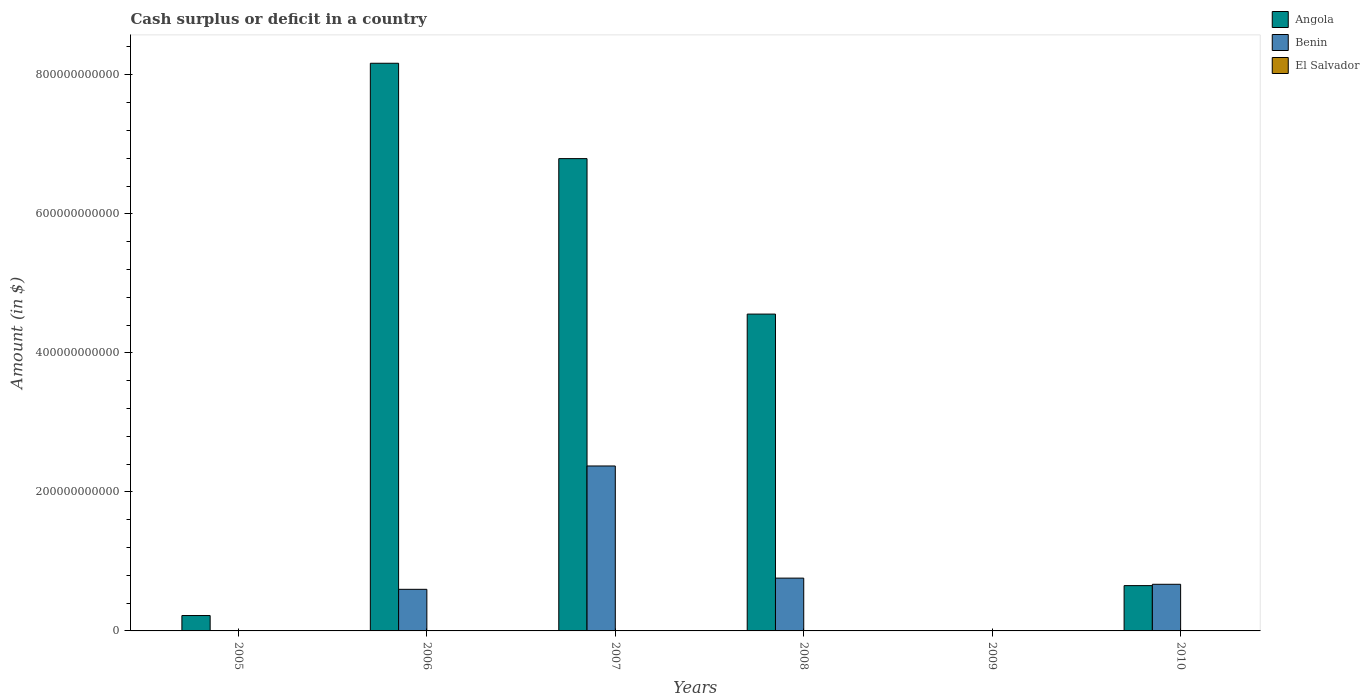How many bars are there on the 3rd tick from the left?
Your answer should be compact. 3. What is the label of the 4th group of bars from the left?
Provide a succinct answer. 2008. In how many cases, is the number of bars for a given year not equal to the number of legend labels?
Make the answer very short. 4. Across all years, what is the maximum amount of cash surplus or deficit in El Salvador?
Ensure brevity in your answer.  1.68e+08. What is the total amount of cash surplus or deficit in El Salvador in the graph?
Your answer should be compact. 2.39e+08. What is the difference between the amount of cash surplus or deficit in Benin in 2006 and that in 2010?
Give a very brief answer. -7.23e+09. What is the difference between the amount of cash surplus or deficit in Angola in 2005 and the amount of cash surplus or deficit in Benin in 2009?
Offer a terse response. 2.21e+1. What is the average amount of cash surplus or deficit in Benin per year?
Make the answer very short. 7.34e+1. In the year 2007, what is the difference between the amount of cash surplus or deficit in El Salvador and amount of cash surplus or deficit in Angola?
Your answer should be compact. -6.79e+11. In how many years, is the amount of cash surplus or deficit in Benin greater than 280000000000 $?
Offer a very short reply. 0. What is the ratio of the amount of cash surplus or deficit in Angola in 2008 to that in 2010?
Your answer should be compact. 6.99. Is the amount of cash surplus or deficit in Benin in 2007 less than that in 2008?
Offer a very short reply. No. What is the difference between the highest and the second highest amount of cash surplus or deficit in Angola?
Ensure brevity in your answer.  1.37e+11. What is the difference between the highest and the lowest amount of cash surplus or deficit in El Salvador?
Your answer should be very brief. 1.68e+08. Is the sum of the amount of cash surplus or deficit in Benin in 2006 and 2008 greater than the maximum amount of cash surplus or deficit in Angola across all years?
Ensure brevity in your answer.  No. Is it the case that in every year, the sum of the amount of cash surplus or deficit in Angola and amount of cash surplus or deficit in Benin is greater than the amount of cash surplus or deficit in El Salvador?
Keep it short and to the point. No. How many bars are there?
Your response must be concise. 11. Are all the bars in the graph horizontal?
Provide a short and direct response. No. How many years are there in the graph?
Give a very brief answer. 6. What is the difference between two consecutive major ticks on the Y-axis?
Provide a short and direct response. 2.00e+11. Are the values on the major ticks of Y-axis written in scientific E-notation?
Offer a terse response. No. Does the graph contain any zero values?
Your response must be concise. Yes. Does the graph contain grids?
Offer a very short reply. No. What is the title of the graph?
Provide a succinct answer. Cash surplus or deficit in a country. What is the label or title of the Y-axis?
Provide a short and direct response. Amount (in $). What is the Amount (in $) in Angola in 2005?
Your answer should be very brief. 2.21e+1. What is the Amount (in $) in Benin in 2005?
Your answer should be compact. 0. What is the Amount (in $) of Angola in 2006?
Ensure brevity in your answer.  8.17e+11. What is the Amount (in $) of Benin in 2006?
Make the answer very short. 5.98e+1. What is the Amount (in $) in Angola in 2007?
Make the answer very short. 6.79e+11. What is the Amount (in $) in Benin in 2007?
Provide a succinct answer. 2.37e+11. What is the Amount (in $) in El Salvador in 2007?
Make the answer very short. 1.68e+08. What is the Amount (in $) of Angola in 2008?
Provide a succinct answer. 4.56e+11. What is the Amount (in $) of Benin in 2008?
Provide a short and direct response. 7.60e+1. What is the Amount (in $) of El Salvador in 2008?
Keep it short and to the point. 7.12e+07. What is the Amount (in $) of Angola in 2009?
Ensure brevity in your answer.  0. What is the Amount (in $) in Angola in 2010?
Provide a succinct answer. 6.52e+1. What is the Amount (in $) of Benin in 2010?
Provide a short and direct response. 6.71e+1. What is the Amount (in $) in El Salvador in 2010?
Keep it short and to the point. 0. Across all years, what is the maximum Amount (in $) of Angola?
Provide a succinct answer. 8.17e+11. Across all years, what is the maximum Amount (in $) in Benin?
Your answer should be compact. 2.37e+11. Across all years, what is the maximum Amount (in $) in El Salvador?
Offer a very short reply. 1.68e+08. Across all years, what is the minimum Amount (in $) of Angola?
Provide a succinct answer. 0. Across all years, what is the minimum Amount (in $) in Benin?
Keep it short and to the point. 0. Across all years, what is the minimum Amount (in $) in El Salvador?
Ensure brevity in your answer.  0. What is the total Amount (in $) in Angola in the graph?
Provide a short and direct response. 2.04e+12. What is the total Amount (in $) of Benin in the graph?
Keep it short and to the point. 4.40e+11. What is the total Amount (in $) of El Salvador in the graph?
Offer a very short reply. 2.39e+08. What is the difference between the Amount (in $) in Angola in 2005 and that in 2006?
Your response must be concise. -7.94e+11. What is the difference between the Amount (in $) in Angola in 2005 and that in 2007?
Your answer should be very brief. -6.57e+11. What is the difference between the Amount (in $) in Angola in 2005 and that in 2008?
Offer a very short reply. -4.34e+11. What is the difference between the Amount (in $) in Angola in 2005 and that in 2010?
Your answer should be very brief. -4.30e+1. What is the difference between the Amount (in $) in Angola in 2006 and that in 2007?
Provide a short and direct response. 1.37e+11. What is the difference between the Amount (in $) in Benin in 2006 and that in 2007?
Offer a very short reply. -1.77e+11. What is the difference between the Amount (in $) of Angola in 2006 and that in 2008?
Offer a terse response. 3.61e+11. What is the difference between the Amount (in $) of Benin in 2006 and that in 2008?
Your answer should be compact. -1.61e+1. What is the difference between the Amount (in $) of Angola in 2006 and that in 2010?
Provide a succinct answer. 7.51e+11. What is the difference between the Amount (in $) in Benin in 2006 and that in 2010?
Your answer should be very brief. -7.23e+09. What is the difference between the Amount (in $) of Angola in 2007 and that in 2008?
Give a very brief answer. 2.24e+11. What is the difference between the Amount (in $) in Benin in 2007 and that in 2008?
Offer a terse response. 1.61e+11. What is the difference between the Amount (in $) in El Salvador in 2007 and that in 2008?
Give a very brief answer. 9.67e+07. What is the difference between the Amount (in $) in Angola in 2007 and that in 2010?
Your answer should be very brief. 6.14e+11. What is the difference between the Amount (in $) of Benin in 2007 and that in 2010?
Your answer should be compact. 1.70e+11. What is the difference between the Amount (in $) of Angola in 2008 and that in 2010?
Your response must be concise. 3.91e+11. What is the difference between the Amount (in $) of Benin in 2008 and that in 2010?
Your answer should be compact. 8.88e+09. What is the difference between the Amount (in $) of Angola in 2005 and the Amount (in $) of Benin in 2006?
Provide a short and direct response. -3.77e+1. What is the difference between the Amount (in $) in Angola in 2005 and the Amount (in $) in Benin in 2007?
Ensure brevity in your answer.  -2.15e+11. What is the difference between the Amount (in $) of Angola in 2005 and the Amount (in $) of El Salvador in 2007?
Offer a very short reply. 2.20e+1. What is the difference between the Amount (in $) in Angola in 2005 and the Amount (in $) in Benin in 2008?
Your answer should be compact. -5.38e+1. What is the difference between the Amount (in $) of Angola in 2005 and the Amount (in $) of El Salvador in 2008?
Ensure brevity in your answer.  2.21e+1. What is the difference between the Amount (in $) of Angola in 2005 and the Amount (in $) of Benin in 2010?
Offer a very short reply. -4.49e+1. What is the difference between the Amount (in $) of Angola in 2006 and the Amount (in $) of Benin in 2007?
Ensure brevity in your answer.  5.79e+11. What is the difference between the Amount (in $) in Angola in 2006 and the Amount (in $) in El Salvador in 2007?
Make the answer very short. 8.16e+11. What is the difference between the Amount (in $) of Benin in 2006 and the Amount (in $) of El Salvador in 2007?
Your response must be concise. 5.97e+1. What is the difference between the Amount (in $) of Angola in 2006 and the Amount (in $) of Benin in 2008?
Provide a succinct answer. 7.41e+11. What is the difference between the Amount (in $) of Angola in 2006 and the Amount (in $) of El Salvador in 2008?
Ensure brevity in your answer.  8.17e+11. What is the difference between the Amount (in $) of Benin in 2006 and the Amount (in $) of El Salvador in 2008?
Ensure brevity in your answer.  5.98e+1. What is the difference between the Amount (in $) in Angola in 2006 and the Amount (in $) in Benin in 2010?
Make the answer very short. 7.50e+11. What is the difference between the Amount (in $) in Angola in 2007 and the Amount (in $) in Benin in 2008?
Offer a very short reply. 6.03e+11. What is the difference between the Amount (in $) in Angola in 2007 and the Amount (in $) in El Salvador in 2008?
Make the answer very short. 6.79e+11. What is the difference between the Amount (in $) of Benin in 2007 and the Amount (in $) of El Salvador in 2008?
Your answer should be compact. 2.37e+11. What is the difference between the Amount (in $) in Angola in 2007 and the Amount (in $) in Benin in 2010?
Make the answer very short. 6.12e+11. What is the difference between the Amount (in $) in Angola in 2008 and the Amount (in $) in Benin in 2010?
Your response must be concise. 3.89e+11. What is the average Amount (in $) in Angola per year?
Offer a very short reply. 3.40e+11. What is the average Amount (in $) of Benin per year?
Your answer should be very brief. 7.34e+1. What is the average Amount (in $) in El Salvador per year?
Ensure brevity in your answer.  3.98e+07. In the year 2006, what is the difference between the Amount (in $) of Angola and Amount (in $) of Benin?
Your answer should be very brief. 7.57e+11. In the year 2007, what is the difference between the Amount (in $) in Angola and Amount (in $) in Benin?
Provide a succinct answer. 4.42e+11. In the year 2007, what is the difference between the Amount (in $) in Angola and Amount (in $) in El Salvador?
Your response must be concise. 6.79e+11. In the year 2007, what is the difference between the Amount (in $) of Benin and Amount (in $) of El Salvador?
Keep it short and to the point. 2.37e+11. In the year 2008, what is the difference between the Amount (in $) in Angola and Amount (in $) in Benin?
Provide a succinct answer. 3.80e+11. In the year 2008, what is the difference between the Amount (in $) in Angola and Amount (in $) in El Salvador?
Offer a very short reply. 4.56e+11. In the year 2008, what is the difference between the Amount (in $) of Benin and Amount (in $) of El Salvador?
Keep it short and to the point. 7.59e+1. In the year 2010, what is the difference between the Amount (in $) of Angola and Amount (in $) of Benin?
Give a very brief answer. -1.92e+09. What is the ratio of the Amount (in $) in Angola in 2005 to that in 2006?
Provide a succinct answer. 0.03. What is the ratio of the Amount (in $) of Angola in 2005 to that in 2007?
Your answer should be compact. 0.03. What is the ratio of the Amount (in $) in Angola in 2005 to that in 2008?
Provide a short and direct response. 0.05. What is the ratio of the Amount (in $) of Angola in 2005 to that in 2010?
Provide a short and direct response. 0.34. What is the ratio of the Amount (in $) of Angola in 2006 to that in 2007?
Your response must be concise. 1.2. What is the ratio of the Amount (in $) of Benin in 2006 to that in 2007?
Your response must be concise. 0.25. What is the ratio of the Amount (in $) of Angola in 2006 to that in 2008?
Make the answer very short. 1.79. What is the ratio of the Amount (in $) in Benin in 2006 to that in 2008?
Offer a very short reply. 0.79. What is the ratio of the Amount (in $) in Angola in 2006 to that in 2010?
Your response must be concise. 12.53. What is the ratio of the Amount (in $) of Benin in 2006 to that in 2010?
Your answer should be compact. 0.89. What is the ratio of the Amount (in $) in Angola in 2007 to that in 2008?
Your answer should be very brief. 1.49. What is the ratio of the Amount (in $) of Benin in 2007 to that in 2008?
Make the answer very short. 3.12. What is the ratio of the Amount (in $) in El Salvador in 2007 to that in 2008?
Your answer should be compact. 2.36. What is the ratio of the Amount (in $) of Angola in 2007 to that in 2010?
Offer a terse response. 10.43. What is the ratio of the Amount (in $) of Benin in 2007 to that in 2010?
Give a very brief answer. 3.54. What is the ratio of the Amount (in $) in Angola in 2008 to that in 2010?
Provide a short and direct response. 6.99. What is the ratio of the Amount (in $) in Benin in 2008 to that in 2010?
Provide a short and direct response. 1.13. What is the difference between the highest and the second highest Amount (in $) in Angola?
Give a very brief answer. 1.37e+11. What is the difference between the highest and the second highest Amount (in $) of Benin?
Give a very brief answer. 1.61e+11. What is the difference between the highest and the lowest Amount (in $) in Angola?
Provide a short and direct response. 8.17e+11. What is the difference between the highest and the lowest Amount (in $) in Benin?
Keep it short and to the point. 2.37e+11. What is the difference between the highest and the lowest Amount (in $) in El Salvador?
Offer a terse response. 1.68e+08. 